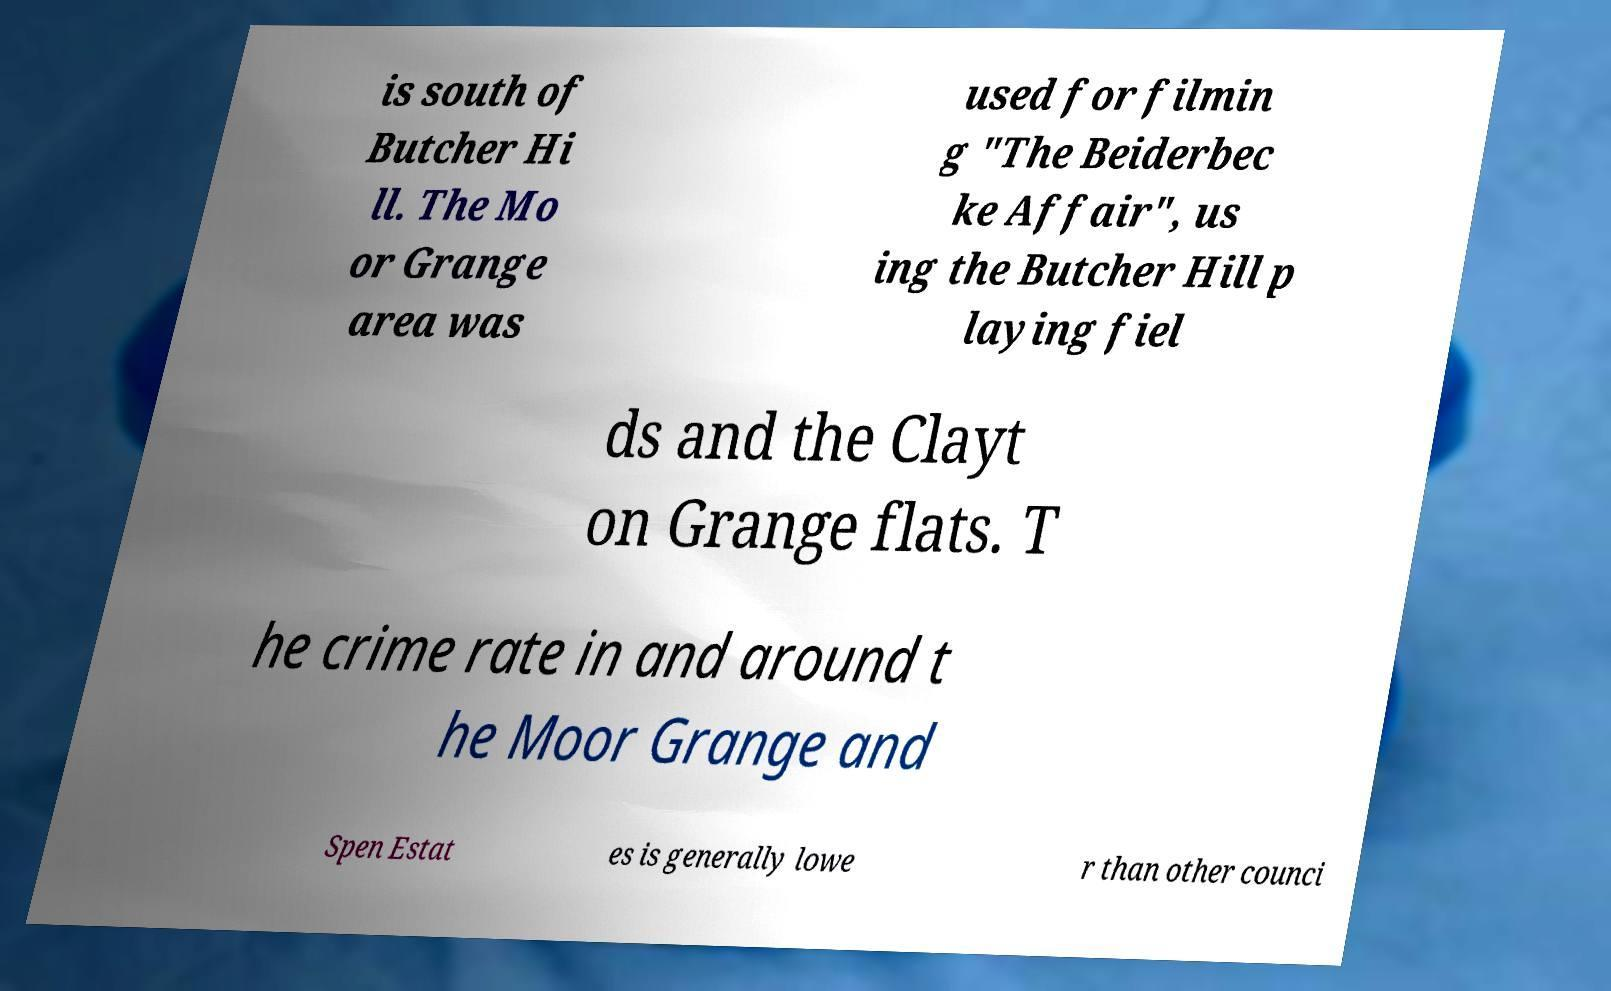Could you extract and type out the text from this image? is south of Butcher Hi ll. The Mo or Grange area was used for filmin g "The Beiderbec ke Affair", us ing the Butcher Hill p laying fiel ds and the Clayt on Grange flats. T he crime rate in and around t he Moor Grange and Spen Estat es is generally lowe r than other counci 